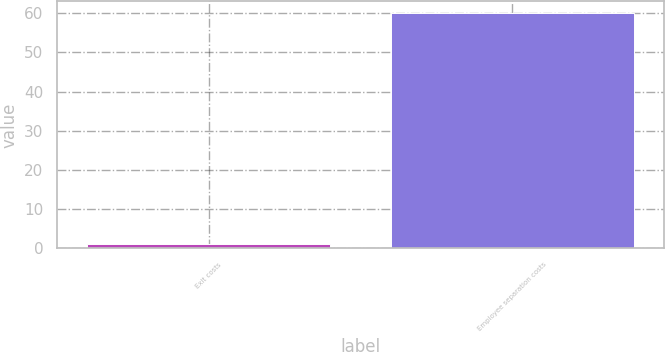Convert chart to OTSL. <chart><loc_0><loc_0><loc_500><loc_500><bar_chart><fcel>Exit costs<fcel>Employee separation costs<nl><fcel>1<fcel>60<nl></chart> 